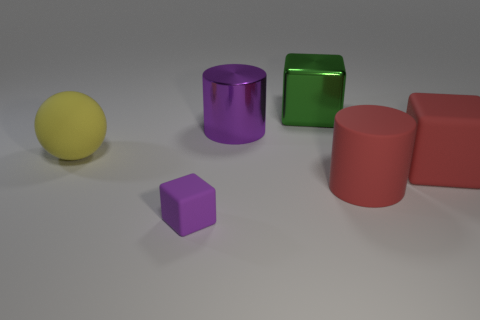Add 2 large objects. How many objects exist? 8 Subtract all cylinders. How many objects are left? 4 Subtract all tiny matte blocks. Subtract all big red blocks. How many objects are left? 4 Add 1 green metallic things. How many green metallic things are left? 2 Add 2 cubes. How many cubes exist? 5 Subtract 0 red balls. How many objects are left? 6 